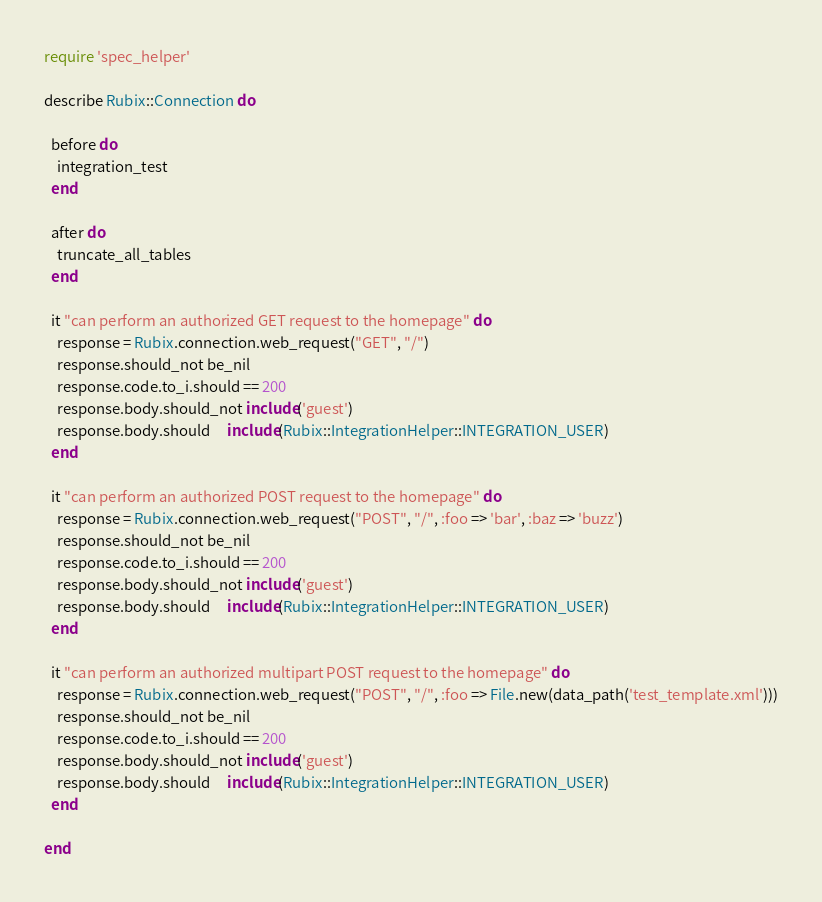<code> <loc_0><loc_0><loc_500><loc_500><_Ruby_>require 'spec_helper'

describe Rubix::Connection do

  before do
    integration_test
  end

  after do
    truncate_all_tables
  end

  it "can perform an authorized GET request to the homepage" do
    response = Rubix.connection.web_request("GET", "/")
    response.should_not be_nil
    response.code.to_i.should == 200
    response.body.should_not include('guest')
    response.body.should     include(Rubix::IntegrationHelper::INTEGRATION_USER)
  end

  it "can perform an authorized POST request to the homepage" do
    response = Rubix.connection.web_request("POST", "/", :foo => 'bar', :baz => 'buzz')
    response.should_not be_nil
    response.code.to_i.should == 200
    response.body.should_not include('guest')
    response.body.should     include(Rubix::IntegrationHelper::INTEGRATION_USER)
  end

  it "can perform an authorized multipart POST request to the homepage" do
    response = Rubix.connection.web_request("POST", "/", :foo => File.new(data_path('test_template.xml')))
    response.should_not be_nil
    response.code.to_i.should == 200
    response.body.should_not include('guest')
    response.body.should     include(Rubix::IntegrationHelper::INTEGRATION_USER)
  end
  
end

</code> 